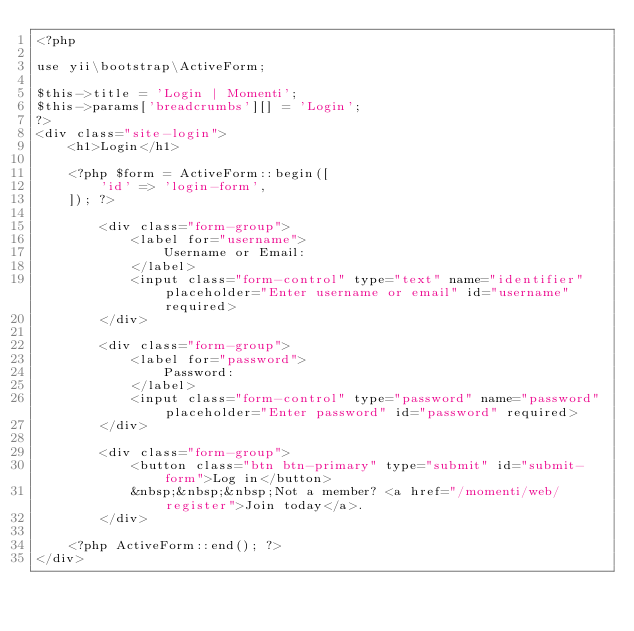<code> <loc_0><loc_0><loc_500><loc_500><_PHP_><?php

use yii\bootstrap\ActiveForm;

$this->title = 'Login | Momenti';
$this->params['breadcrumbs'][] = 'Login';
?>
<div class="site-login">
    <h1>Login</h1>

    <?php $form = ActiveForm::begin([
        'id' => 'login-form',
    ]); ?>

        <div class="form-group">
            <label for="username">
                Username or Email:
            </label>
            <input class="form-control" type="text" name="identifier" placeholder="Enter username or email" id="username" required>
        </div>

        <div class="form-group">
            <label for="password">
                Password:
            </label>
            <input class="form-control" type="password" name="password" placeholder="Enter password" id="password" required>
        </div>

        <div class="form-group">
            <button class="btn btn-primary" type="submit" id="submit-form">Log in</button>
            &nbsp;&nbsp;&nbsp;Not a member? <a href="/momenti/web/register">Join today</a>.
        </div>

    <?php ActiveForm::end(); ?>
</div>
</code> 